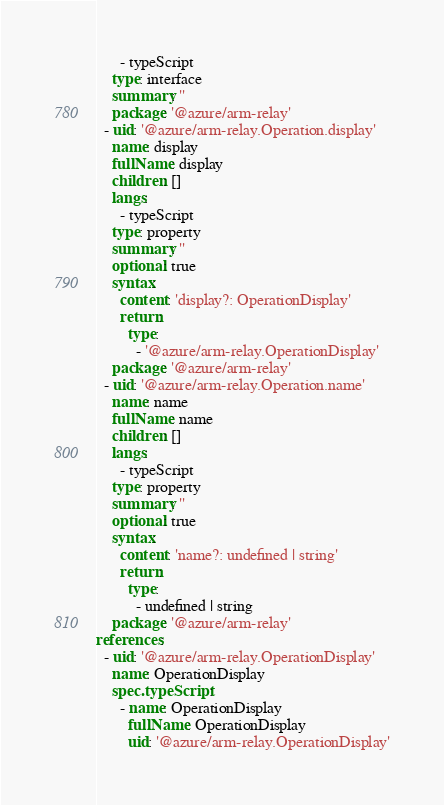Convert code to text. <code><loc_0><loc_0><loc_500><loc_500><_YAML_>      - typeScript
    type: interface
    summary: ''
    package: '@azure/arm-relay'
  - uid: '@azure/arm-relay.Operation.display'
    name: display
    fullName: display
    children: []
    langs:
      - typeScript
    type: property
    summary: ''
    optional: true
    syntax:
      content: 'display?: OperationDisplay'
      return:
        type:
          - '@azure/arm-relay.OperationDisplay'
    package: '@azure/arm-relay'
  - uid: '@azure/arm-relay.Operation.name'
    name: name
    fullName: name
    children: []
    langs:
      - typeScript
    type: property
    summary: ''
    optional: true
    syntax:
      content: 'name?: undefined | string'
      return:
        type:
          - undefined | string
    package: '@azure/arm-relay'
references:
  - uid: '@azure/arm-relay.OperationDisplay'
    name: OperationDisplay
    spec.typeScript:
      - name: OperationDisplay
        fullName: OperationDisplay
        uid: '@azure/arm-relay.OperationDisplay'
</code> 